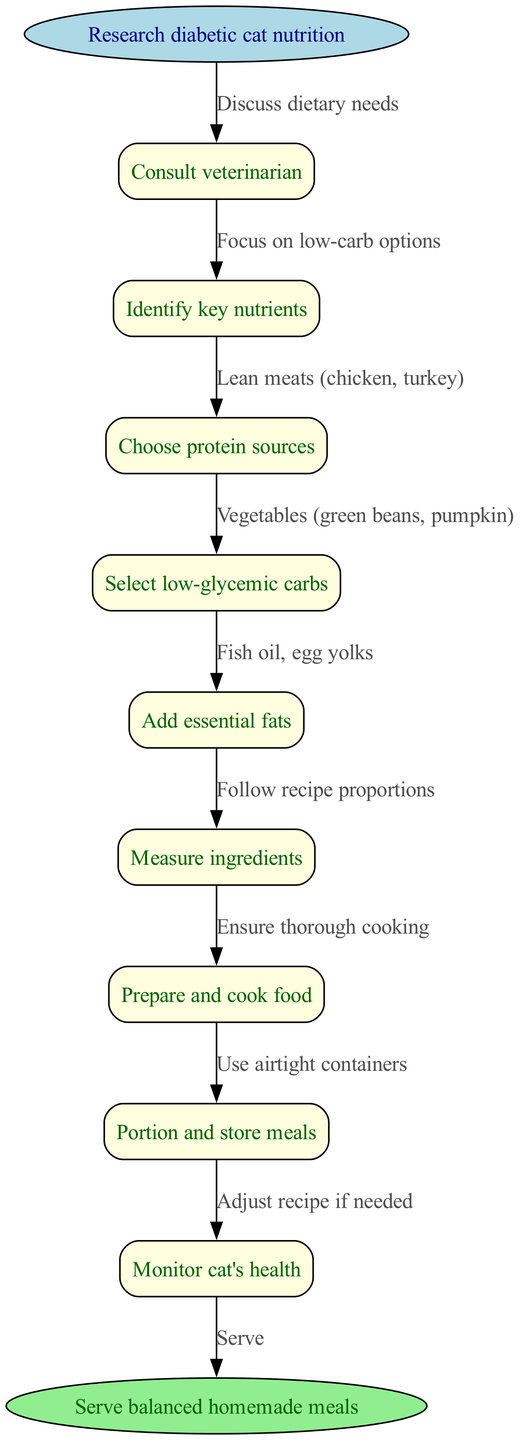What is the first step in the diagram? The first step in the diagram is labeled "Research diabetic cat nutrition," which is the starting node. It identifies where the process begins.
Answer: Research diabetic cat nutrition How many nodes are present in the diagram? The diagram contains a total of 10 nodes: 1 start node, 8 intermediate nodes, and 1 end node, which represent the flow of creating a balanced diet for diabetic cats.
Answer: 10 What nutrient category is discussed after choosing protein sources? The next category discussed after "Choose protein sources" is "Select low-glycemic carbs," indicating the flow from one category to the next in the nutritional planning.
Answer: Select low-glycemic carbs What kind of food sources are recommended for essential fats? The node suggests "Fish oil, egg yolks" as sources of essential fats, indicating the specific components to add to the diet.
Answer: Fish oil, egg yolks What should be monitored to ensure the diet is effective? The node states "Monitor cat's health," emphasizing that health status is critical in assessing the success of the homemade diet.
Answer: Monitor cat's health What step follows after adding essential fats? After "Add essential fats," the next step in the sequence is "Measure ingredients," showing the process of preparing to make the food.
Answer: Measure ingredients What is the purpose of the edge from "Prepare and cook food" to "Portion and store meals"? The edge signifies the transition in the workflow, indicating that once food is prepared and cooked, it should be portioned and stored appropriately for later use.
Answer: Portion and store meals What must be done if the recipe needs adjustment? The diagram indicates to "Adjust recipe if needed," suggesting that changes may be necessary based on the cat's response to the diet.
Answer: Adjust recipe if needed What shape is used for the start and end nodes? The start and end nodes are represented in an ellipse shape, which typically signifies the beginning and conclusion of a process in flowcharts.
Answer: Ellipse 